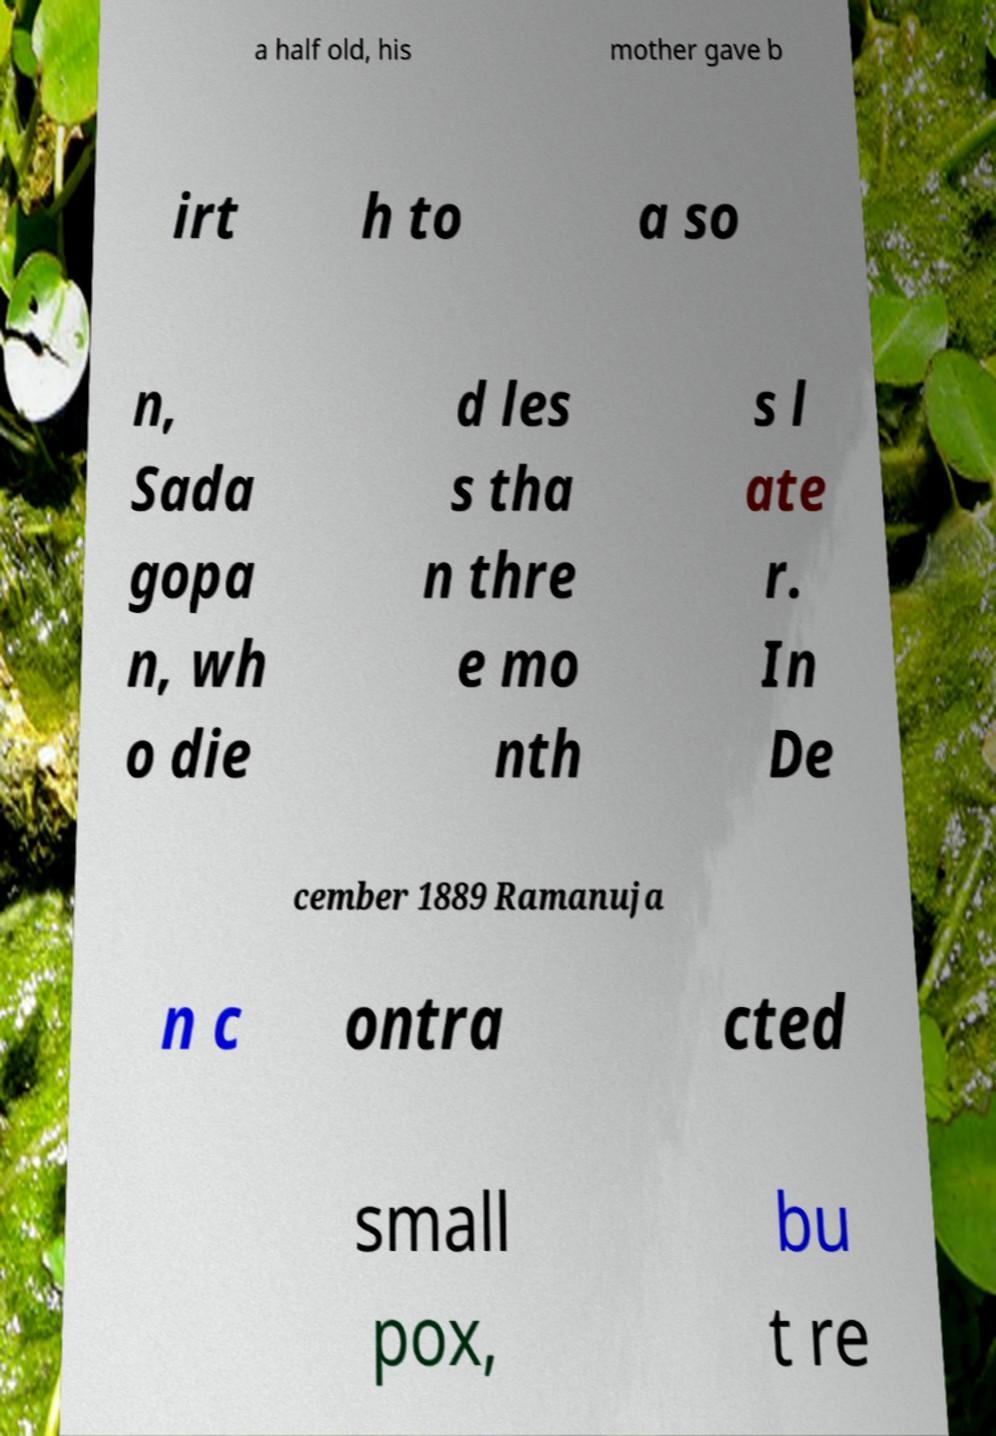Could you extract and type out the text from this image? a half old, his mother gave b irt h to a so n, Sada gopa n, wh o die d les s tha n thre e mo nth s l ate r. In De cember 1889 Ramanuja n c ontra cted small pox, bu t re 